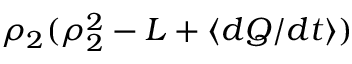<formula> <loc_0><loc_0><loc_500><loc_500>\rho _ { 2 } ( \rho _ { 2 } ^ { 2 } - L + \langle d Q / d t \rangle )</formula> 